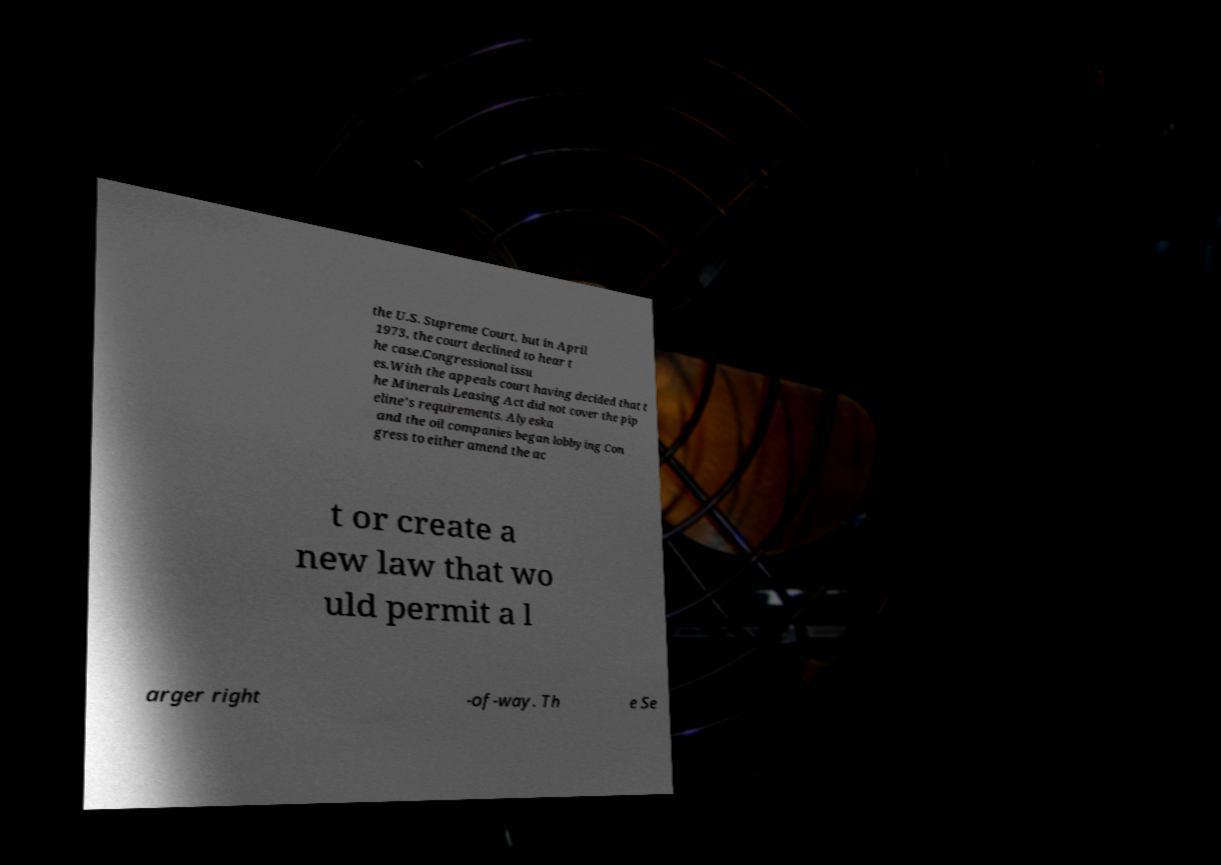Can you accurately transcribe the text from the provided image for me? the U.S. Supreme Court, but in April 1973, the court declined to hear t he case.Congressional issu es.With the appeals court having decided that t he Minerals Leasing Act did not cover the pip eline's requirements, Alyeska and the oil companies began lobbying Con gress to either amend the ac t or create a new law that wo uld permit a l arger right -of-way. Th e Se 